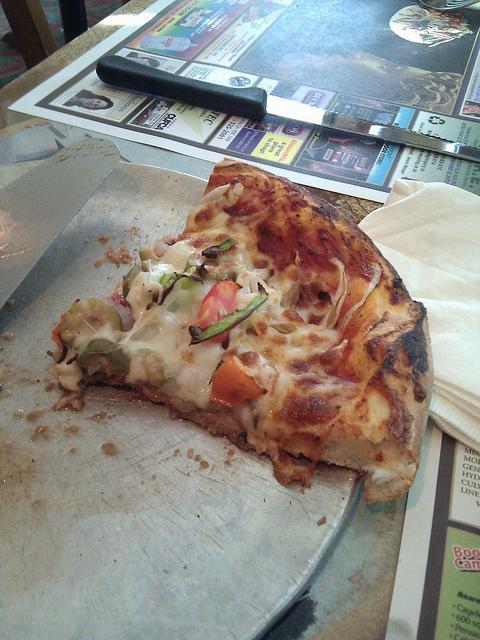How many pieces of pizza are there?
Give a very brief answer. 1. How many dogs are on he bench in this image?
Give a very brief answer. 0. 